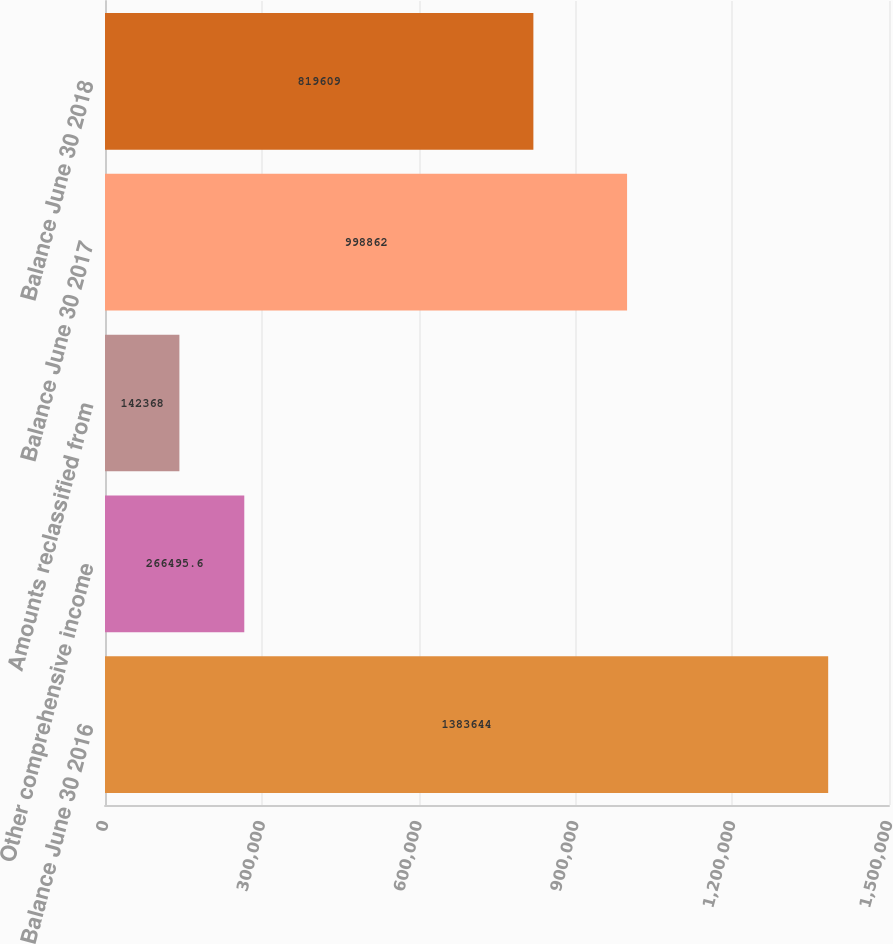Convert chart. <chart><loc_0><loc_0><loc_500><loc_500><bar_chart><fcel>Balance June 30 2016<fcel>Other comprehensive income<fcel>Amounts reclassified from<fcel>Balance June 30 2017<fcel>Balance June 30 2018<nl><fcel>1.38364e+06<fcel>266496<fcel>142368<fcel>998862<fcel>819609<nl></chart> 